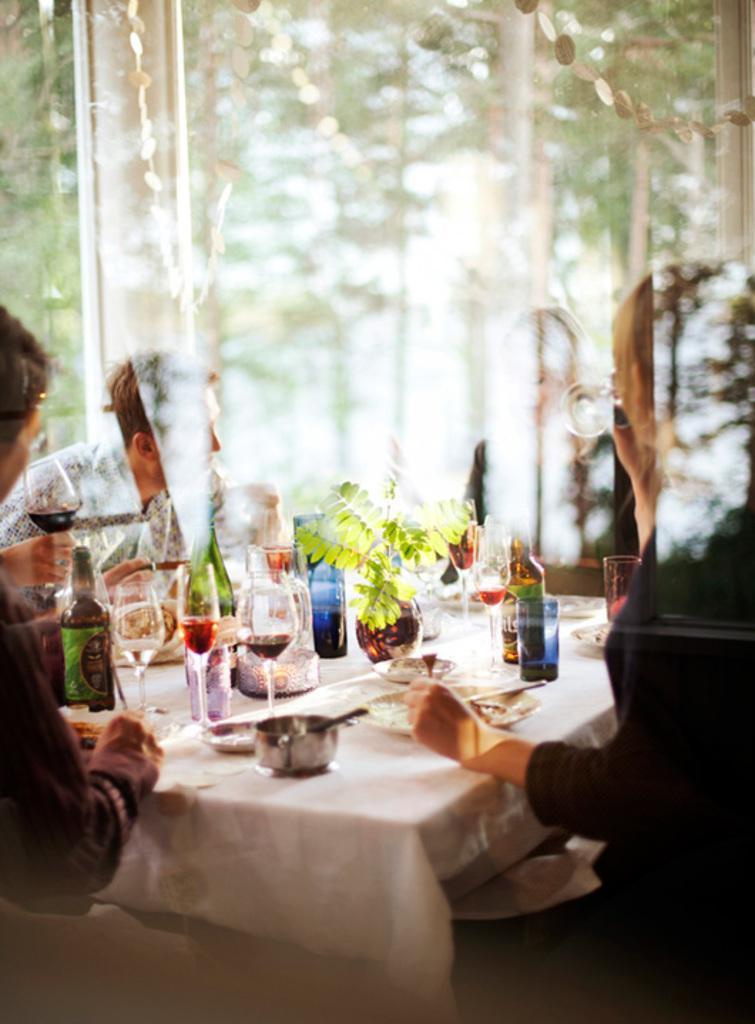In one or two sentences, can you explain what this image depicts? In this image there is a table, on that table there are glasses, bottles, plates, cups, around the table there are people sitting on chairs, in the background it is blurred. 